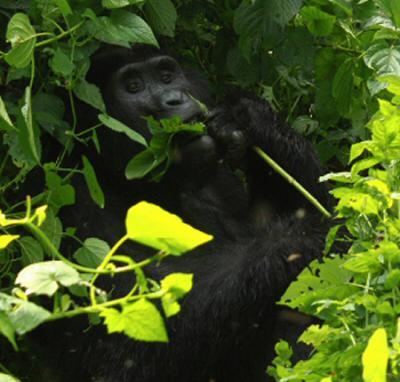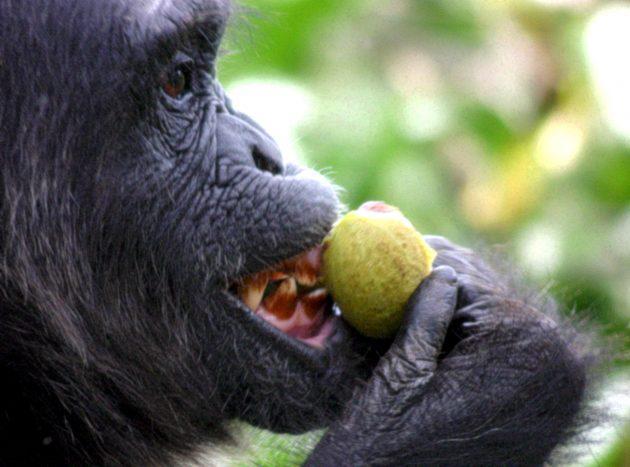The first image is the image on the left, the second image is the image on the right. Evaluate the accuracy of this statement regarding the images: "One of the images in the pair includes a baby gorilla.". Is it true? Answer yes or no. No. The first image is the image on the left, the second image is the image on the right. Analyze the images presented: Is the assertion "The left image shows one gorilla holding a leafless stalk to its mouth, and the right image includes a fuzzy-haired young gorilla looking over its shoulder toward the camera." valid? Answer yes or no. No. 